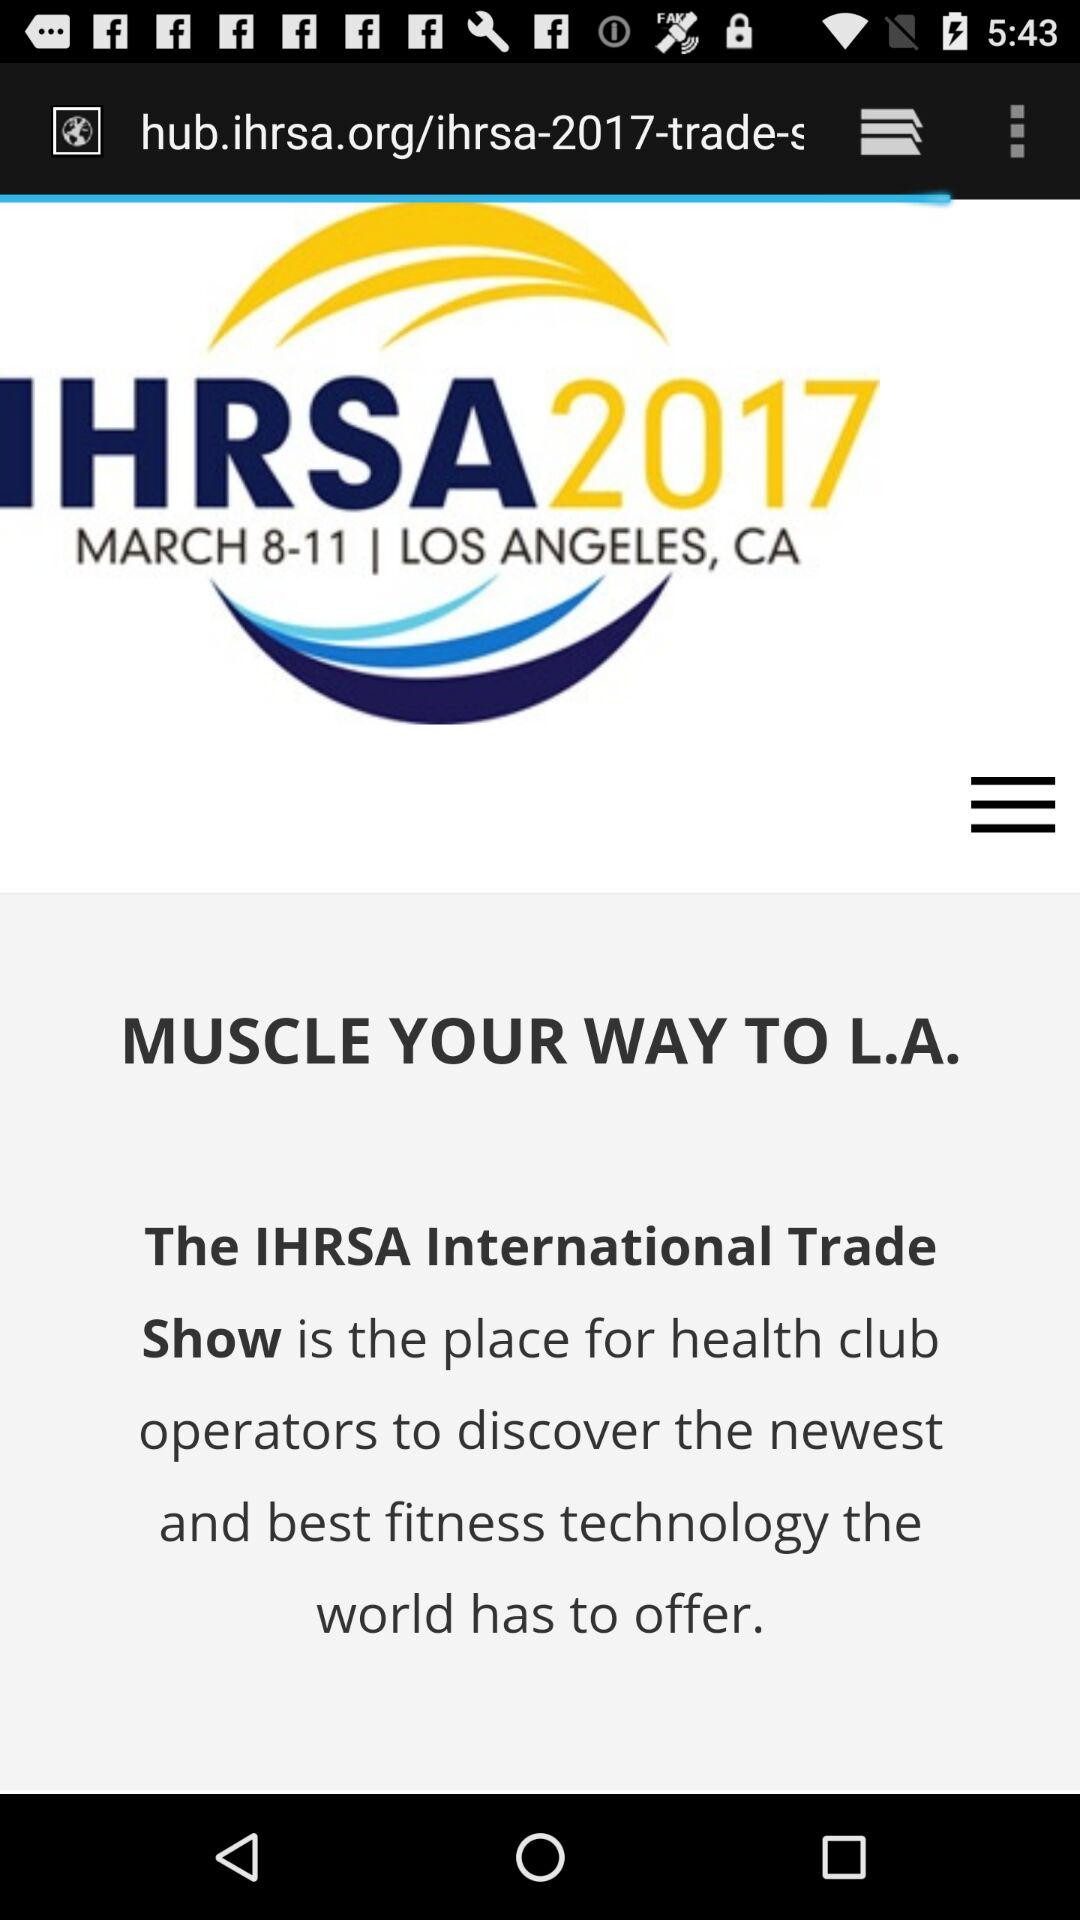In which city was the show organized? The show was organized in Los Angeles. 